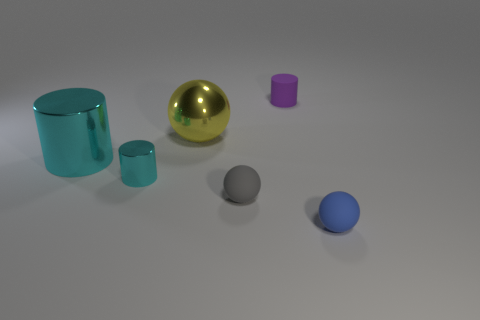Subtract all tiny spheres. How many spheres are left? 1 Subtract all brown cubes. How many cyan cylinders are left? 2 Subtract 1 balls. How many balls are left? 2 Add 3 yellow spheres. How many objects exist? 9 Add 3 yellow spheres. How many yellow spheres are left? 4 Add 1 cyan shiny objects. How many cyan shiny objects exist? 3 Subtract 1 blue spheres. How many objects are left? 5 Subtract all purple balls. Subtract all gray blocks. How many balls are left? 3 Subtract all big yellow things. Subtract all tiny cyan metal cylinders. How many objects are left? 4 